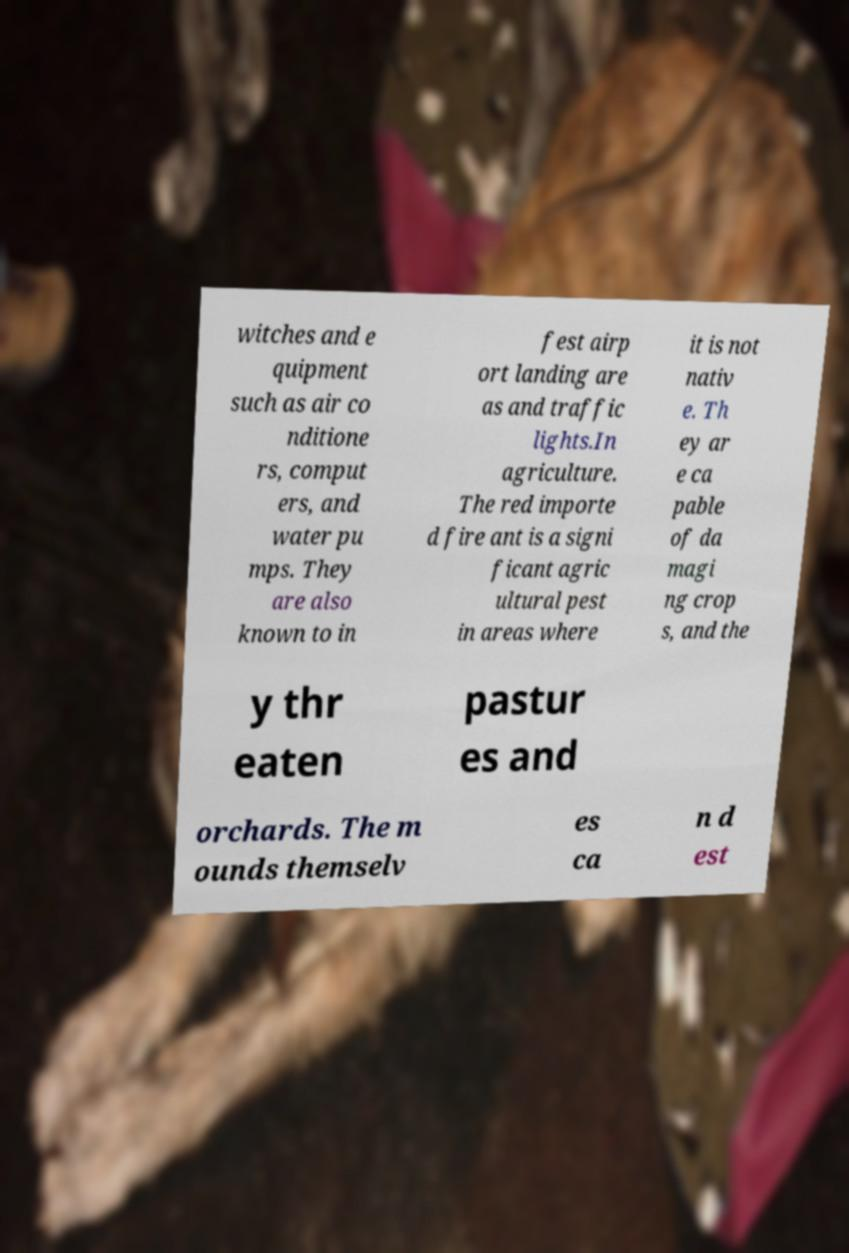There's text embedded in this image that I need extracted. Can you transcribe it verbatim? witches and e quipment such as air co nditione rs, comput ers, and water pu mps. They are also known to in fest airp ort landing are as and traffic lights.In agriculture. The red importe d fire ant is a signi ficant agric ultural pest in areas where it is not nativ e. Th ey ar e ca pable of da magi ng crop s, and the y thr eaten pastur es and orchards. The m ounds themselv es ca n d est 